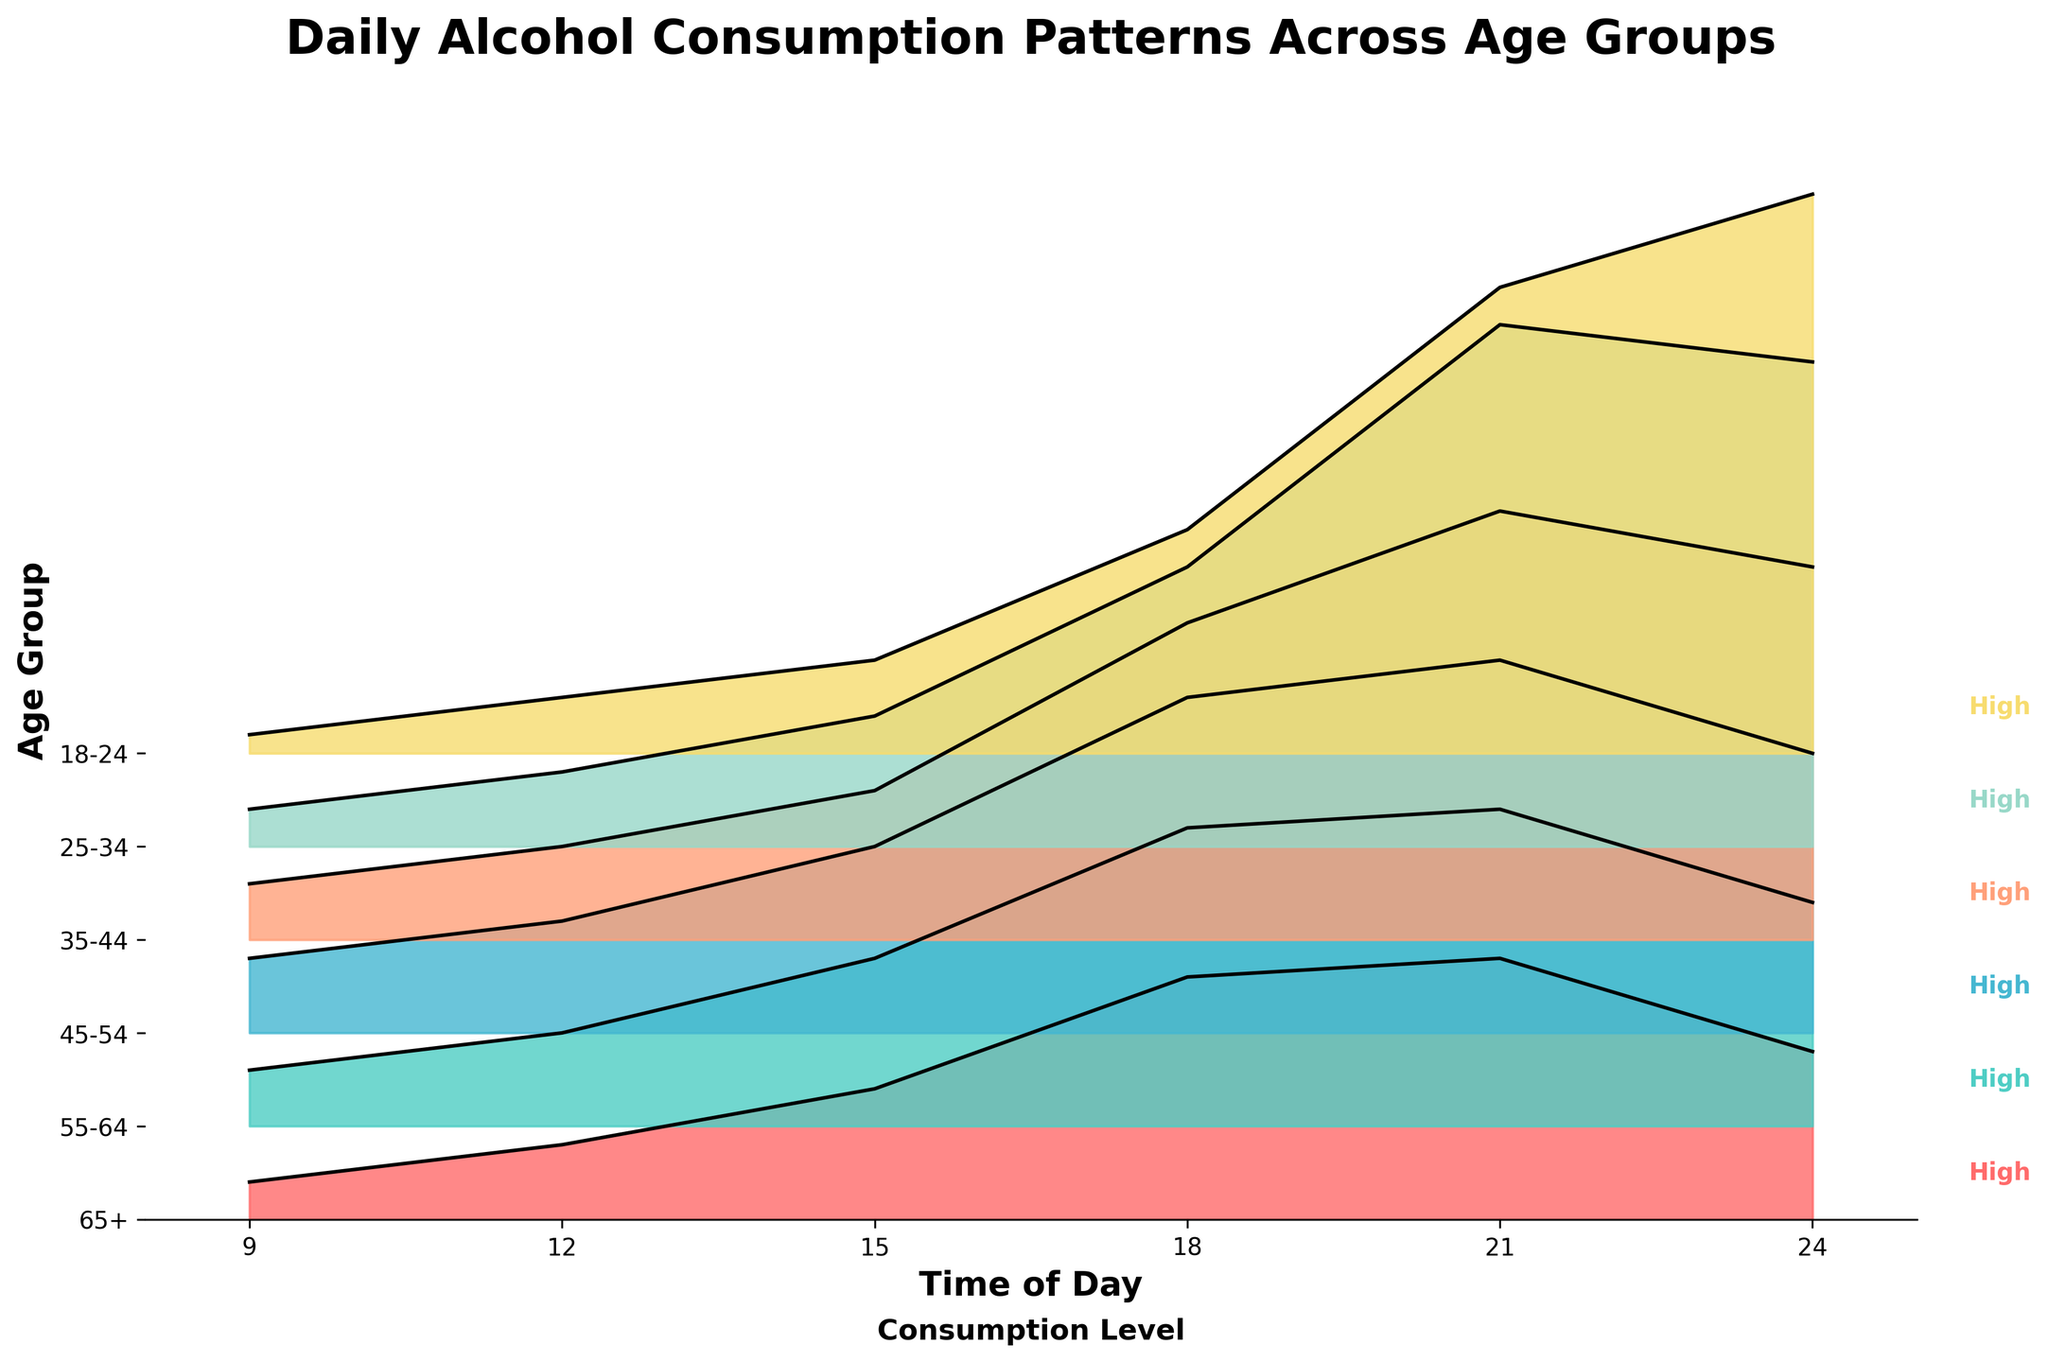What is the title of the plot? The title of the plot is the text located at the top of the figure, which usually gives an overview of what the figure represents. In this case, the title is "Daily Alcohol Consumption Patterns Across Age Groups".
Answer: Daily Alcohol Consumption Patterns Across Age Groups How many age groups are represented in the plot? Age groups are represented along the y-axis of the Ridgeline plot. Each distinct label on the y-axis corresponds to an age group.
Answer: 6 Which age group has the highest alcohol consumption level at 9 PM? To determine this, find the 21 (9 PM) marker on the x-axis and trace the consumption levels for each age group. The group with the highest value at this time is what we are looking for. The highest consumption level at 9 PM is seen in the 25-34 age group.
Answer: 25-34 What is the consumption level for the 45-54 age group at midnight? Locate the 24 (midnight) time point along the x-axis and check the corresponding consumption level for the 45-54 age group. According to the plot, the consumption level is 1.5.
Answer: 1.5 Which age group shows the steepest increase in alcohol consumption in the evening hours (6 PM - 9 PM)? To find the steepest increase, examine the slope of the lines between 18 (6 PM) and 21 (9 PM). The steepest increase is given by the line with the highest gradient. The 18-24 age group shows the steepest increase from 1.2 to 2.5 during this period.
Answer: 18-24 At what time of day do the 35-44 age group have their highest consumption of alcohol? We need to identify the peak point for the line representing the 35-44 age group. The peak is at 21 (9 PM) with a consumption level of 2.3.
Answer: 9 PM Compare the alcohol consumption levels of the 55-64 and 65+ age groups at 6 PM. Which group consumes more? Locate 18 (6 PM) along the x-axis and find the corresponding consumption levels for the 55-64 and 65+ age groups. The 55-64 group has a consumption level of 1.6, whereas the 65+ group has a consumption level of 1.3, making the 55-64 group higher.
Answer: 55-64 What is the average alcohol consumption level for the 25-34 age group from 6 PM to midnight? Calculate the average of the consumption levels at 18 (1.5), 21 (2.8), and 24 (2.6). The sum is 1.5 + 2.8 + 2.6 = 6.9, so the average is 6.9/3 = 2.3.
Answer: 2.3 Which age group shows a decrease in consumption level from 9 PM to midnight? Look for the age group whose line declines from the peak at 21 (9 PM) to 24 (midnight). The 35-44 age group drops from 2.3 to 2.0, and the 45-54 age group drops from 2.0 to 1.5.
Answer: 35-44, 45-54 